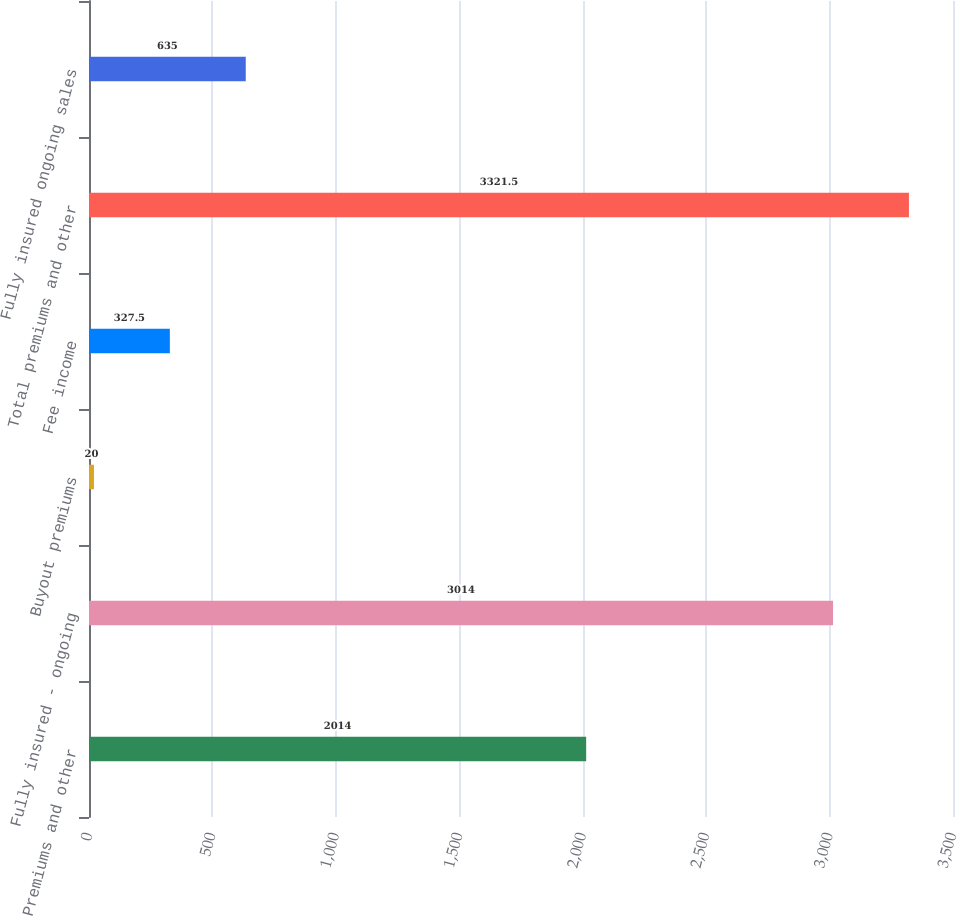<chart> <loc_0><loc_0><loc_500><loc_500><bar_chart><fcel>Premiums and other<fcel>Fully insured - ongoing<fcel>Buyout premiums<fcel>Fee income<fcel>Total premiums and other<fcel>Fully insured ongoing sales<nl><fcel>2014<fcel>3014<fcel>20<fcel>327.5<fcel>3321.5<fcel>635<nl></chart> 